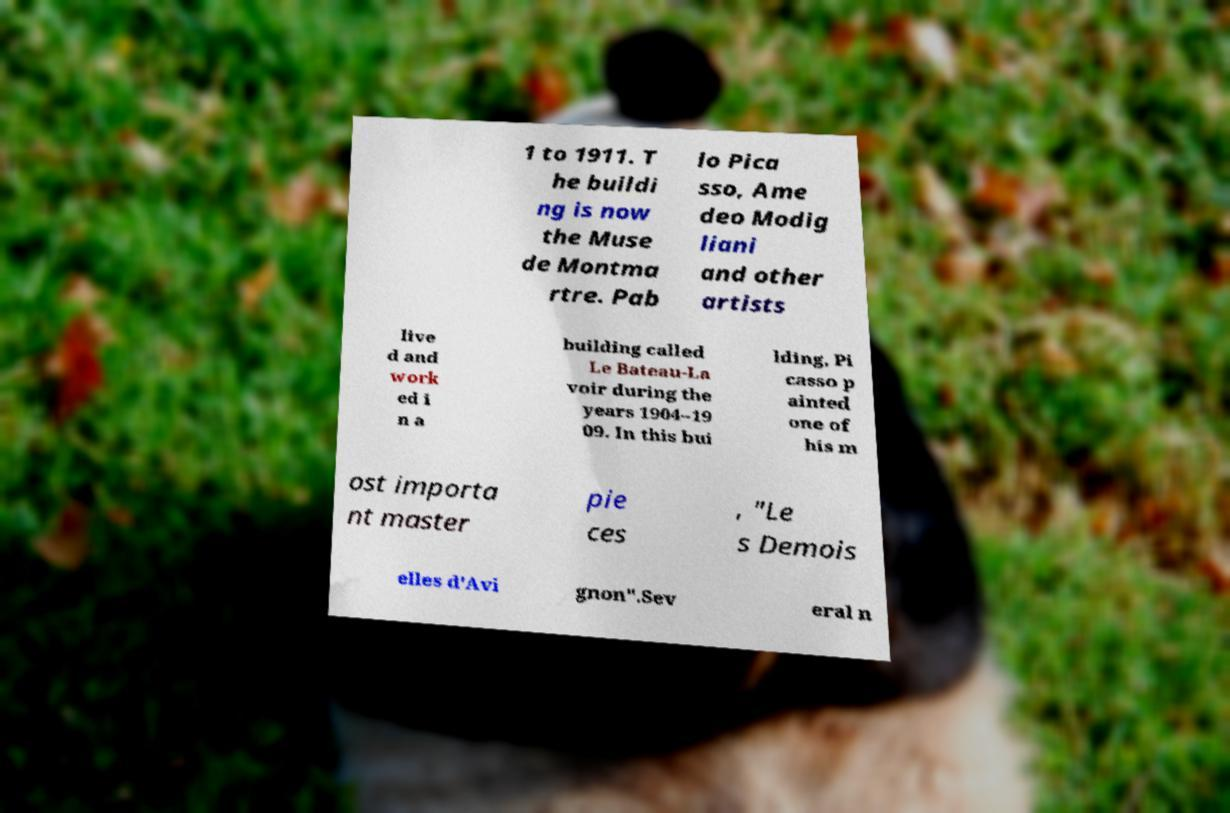Can you read and provide the text displayed in the image?This photo seems to have some interesting text. Can you extract and type it out for me? 1 to 1911. T he buildi ng is now the Muse de Montma rtre. Pab lo Pica sso, Ame deo Modig liani and other artists live d and work ed i n a building called Le Bateau-La voir during the years 1904–19 09. In this bui lding, Pi casso p ainted one of his m ost importa nt master pie ces , "Le s Demois elles d'Avi gnon".Sev eral n 